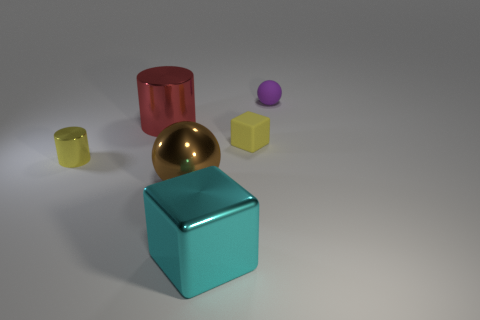Add 2 blocks. How many objects exist? 8 Subtract all brown spheres. How many spheres are left? 1 Subtract 1 balls. How many balls are left? 1 Subtract all cyan cylinders. Subtract all brown blocks. How many cylinders are left? 2 Subtract all small cyan metallic cubes. Subtract all brown objects. How many objects are left? 5 Add 1 big things. How many big things are left? 4 Add 4 brown objects. How many brown objects exist? 5 Subtract 0 yellow balls. How many objects are left? 6 